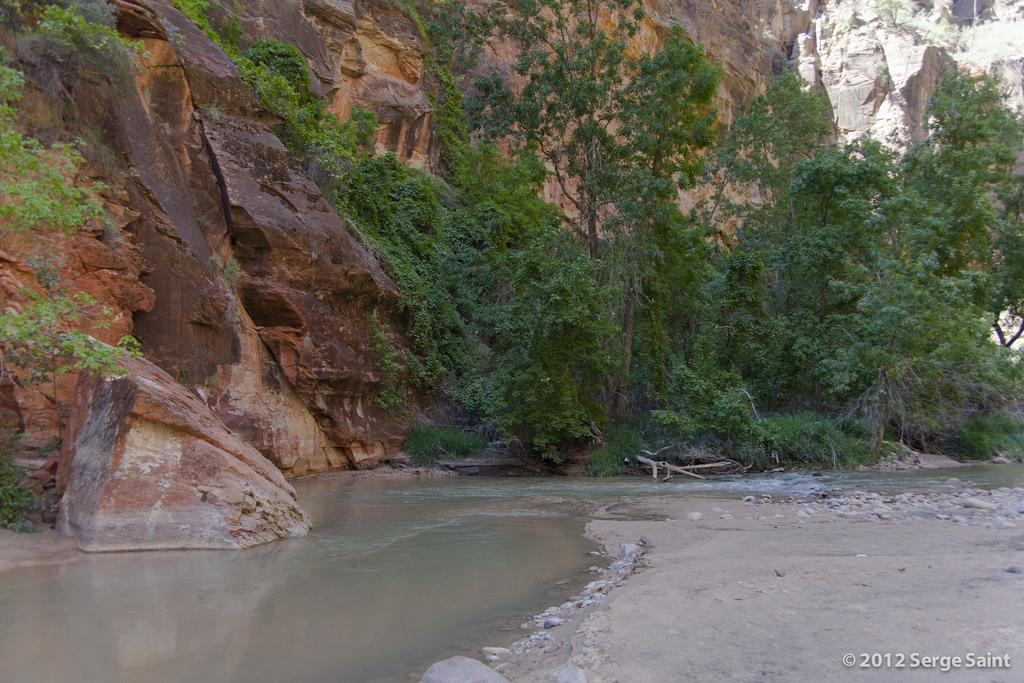What type of landscape is depicted in the image? The image features hills, trees, stones, water, and sand, suggesting a natural landscape. Can you describe the vegetation in the image? There are trees visible in the image. What type of terrain can be seen in the image? The image includes stones and sand, indicating a mix of rocky and sandy terrain. Is there any water visible in the image? Yes, there is water visible in the image. What scent can be detected from the image? There is no scent present in the image, as it is a visual representation. Can you compare the night sky in the image to the daytime sky? There is no reference to a sky or time of day in the image, so it is not possible to make a comparison. 